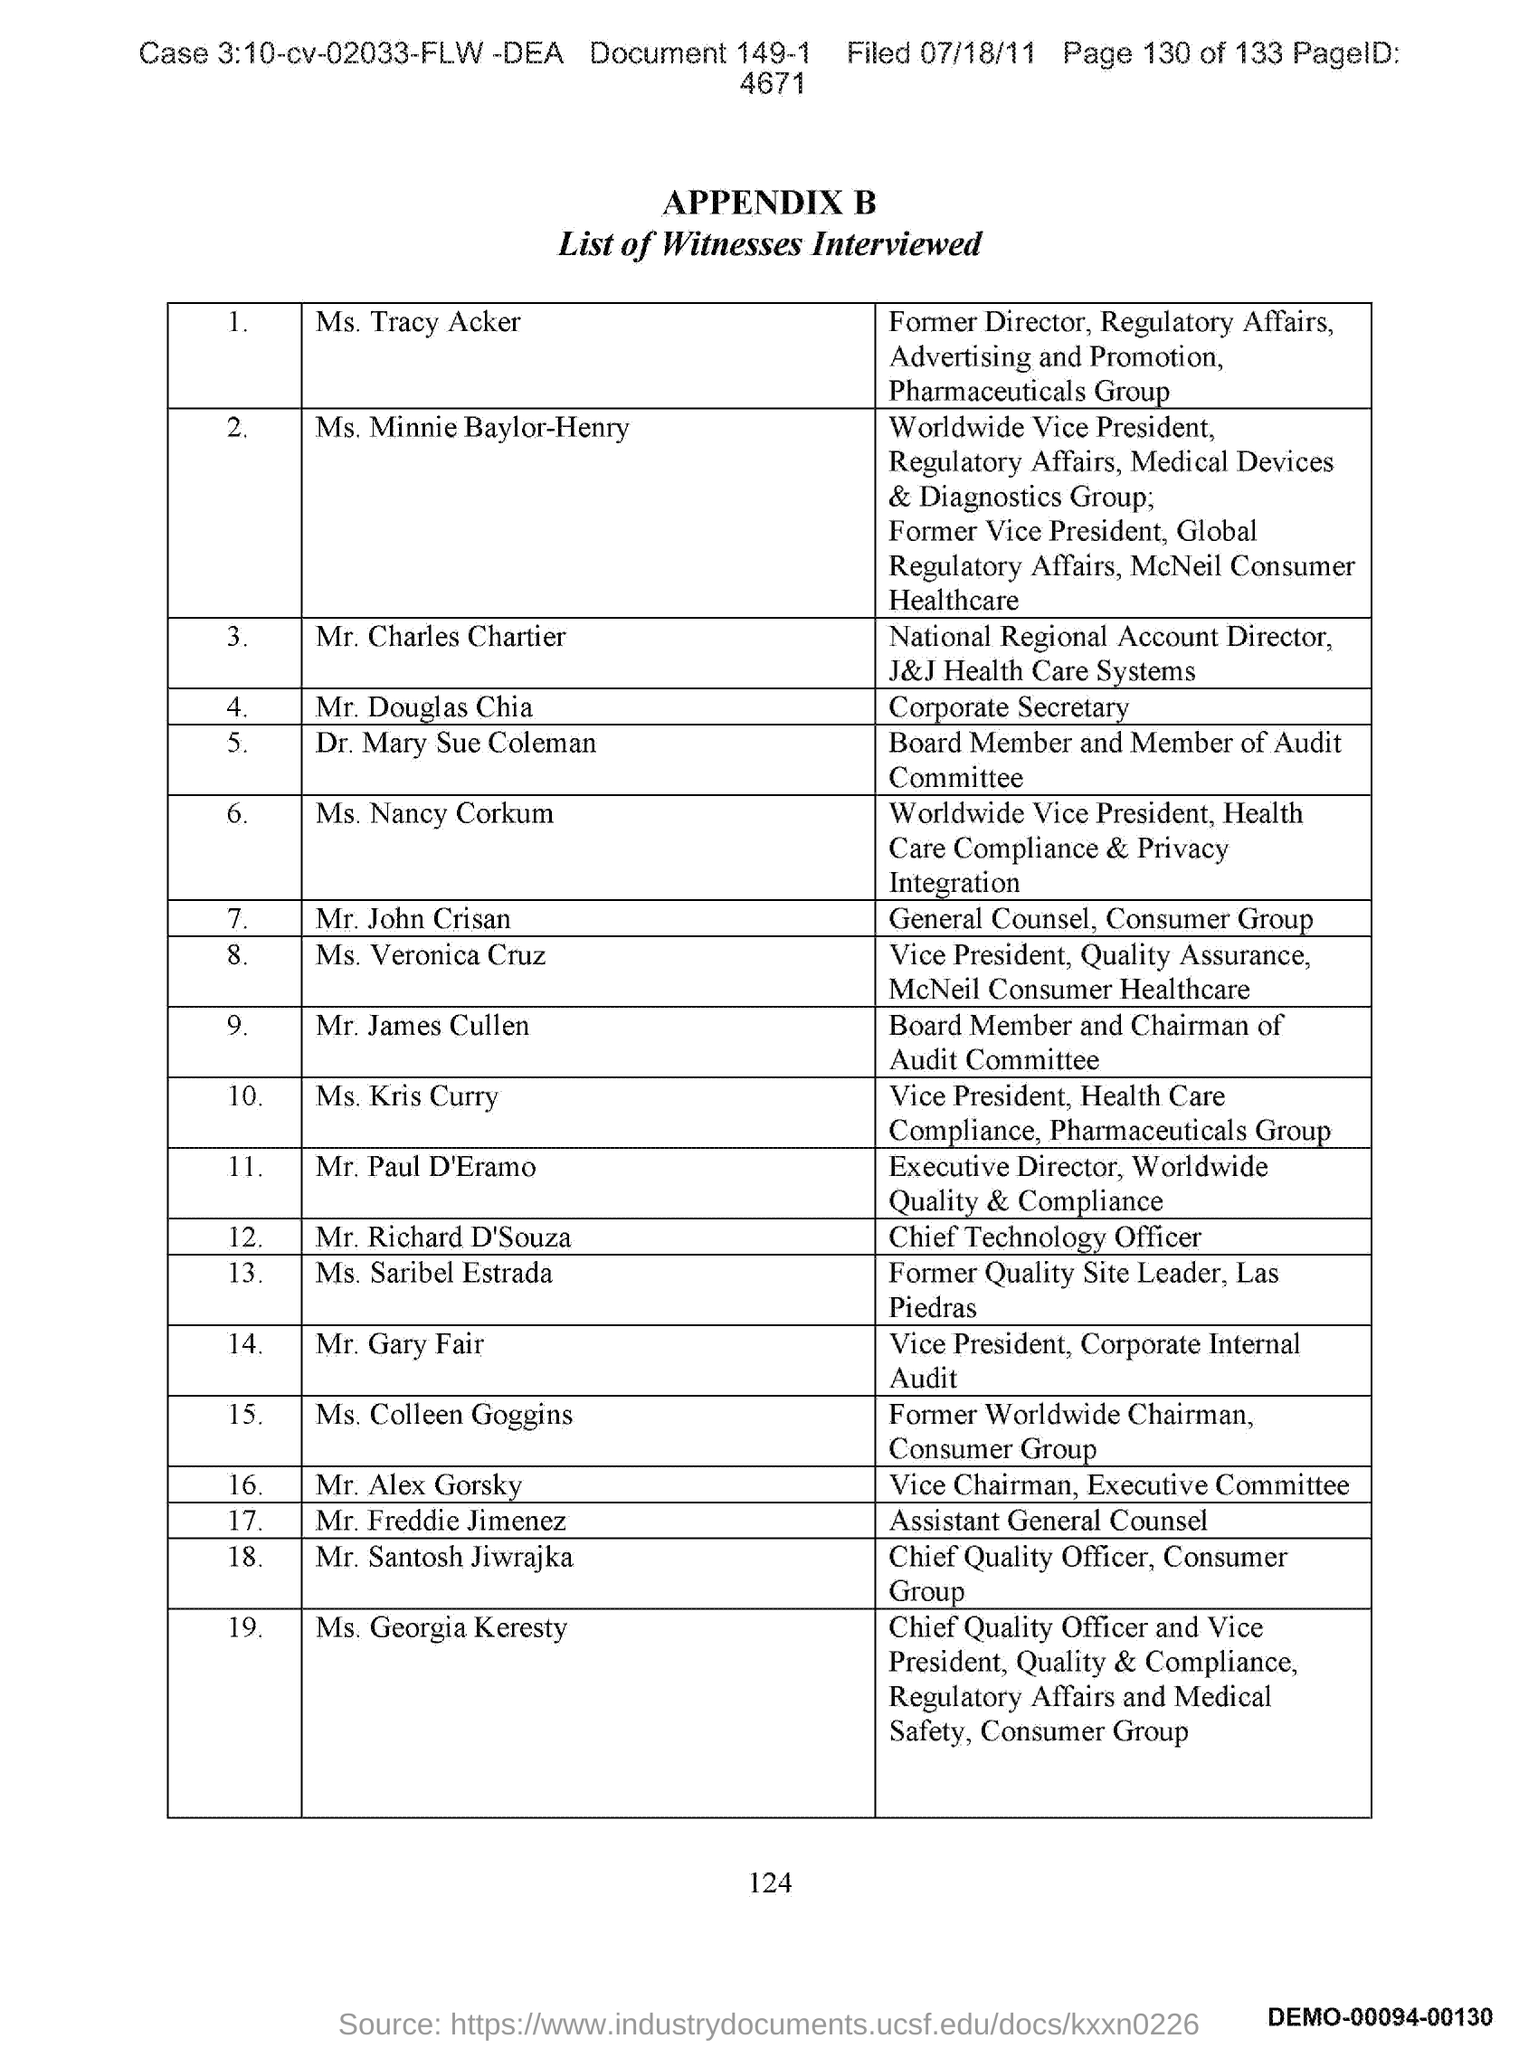List a handful of essential elements in this visual. The Chief Quality Officer of the Consumer Group is Mr. Santosh Jiwrajka. The Vice President of Corporate Internal Audit is named Mr. Gary Fair. John Crisan is the General Counsel of a Consumer Group. The Chief Technology Officer is Mr. Richard D'Souza. Who is the Corporate Secretary? The Corporate Secretary is Douglas Chia. 